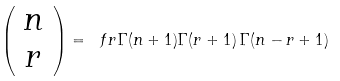Convert formula to latex. <formula><loc_0><loc_0><loc_500><loc_500>\left ( \begin{array} { c } n \\ r \end{array} \right ) = \ f r { \Gamma ( n + 1 ) } { \Gamma ( r + 1 ) \, \Gamma ( n - r + 1 ) }</formula> 